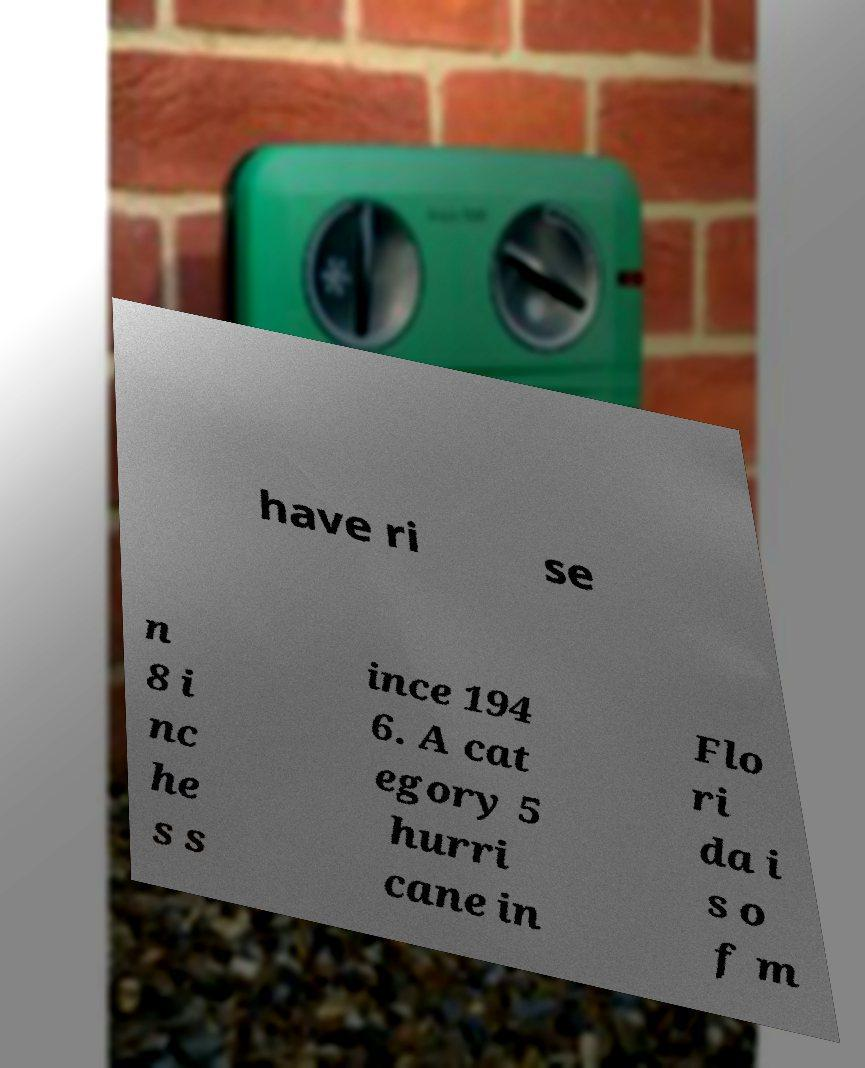Could you assist in decoding the text presented in this image and type it out clearly? have ri se n 8 i nc he s s ince 194 6. A cat egory 5 hurri cane in Flo ri da i s o f m 